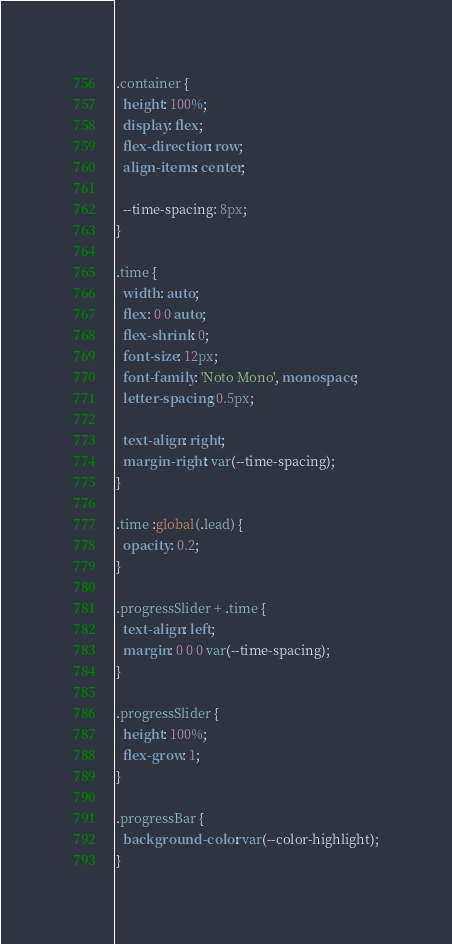<code> <loc_0><loc_0><loc_500><loc_500><_CSS_>.container {
  height: 100%;
  display: flex;
  flex-direction: row;
  align-items: center;

  --time-spacing: 8px;
}

.time {
  width: auto;
  flex: 0 0 auto;
  flex-shrink: 0;
  font-size: 12px;
  font-family: 'Noto Mono', monospace;
  letter-spacing: 0.5px;

  text-align: right;
  margin-right: var(--time-spacing);
}

.time :global(.lead) {
  opacity: 0.2;
}

.progressSlider + .time {
  text-align: left;
  margin: 0 0 0 var(--time-spacing);
}

.progressSlider {
  height: 100%;
  flex-grow: 1;
}

.progressBar {
  background-color: var(--color-highlight);
}
</code> 